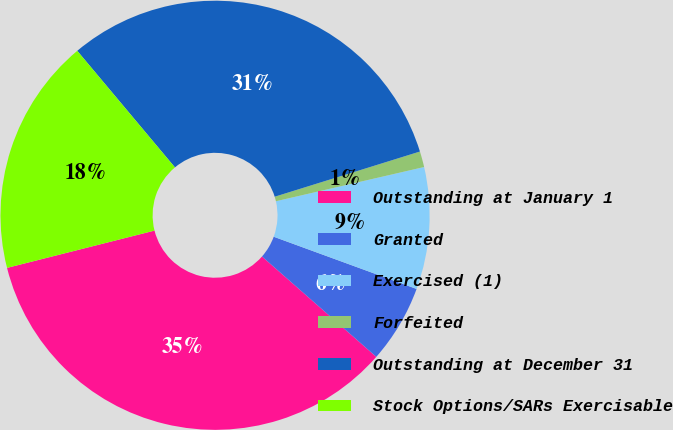Convert chart to OTSL. <chart><loc_0><loc_0><loc_500><loc_500><pie_chart><fcel>Outstanding at January 1<fcel>Granted<fcel>Exercised (1)<fcel>Forfeited<fcel>Outstanding at December 31<fcel>Stock Options/SARs Exercisable<nl><fcel>34.59%<fcel>5.89%<fcel>9.19%<fcel>1.19%<fcel>31.3%<fcel>17.84%<nl></chart> 